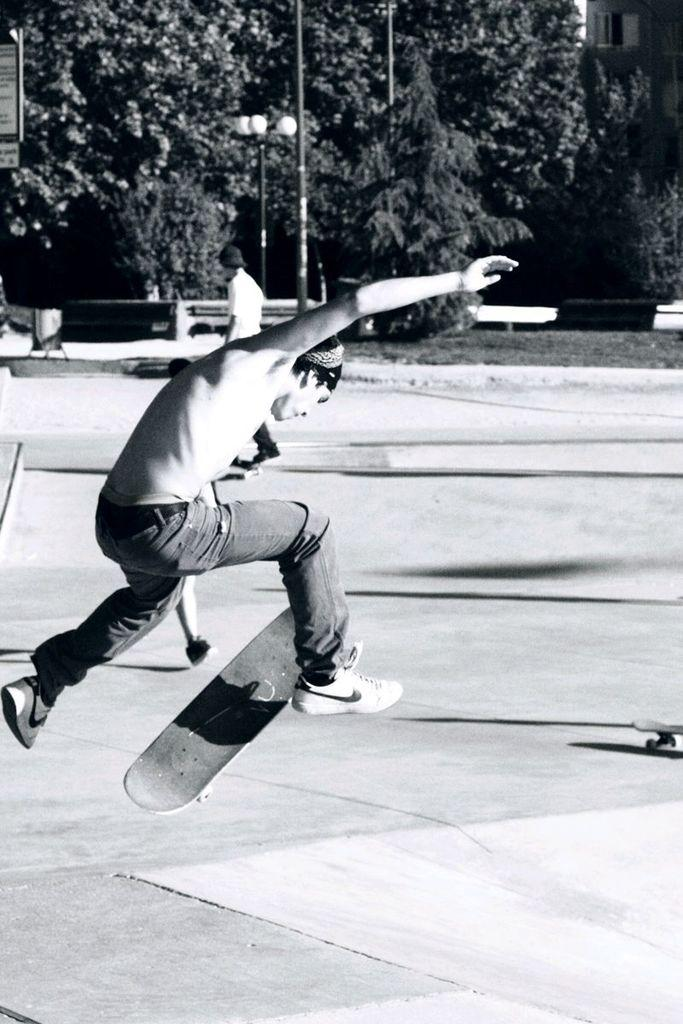Who is the main subject in the image? There is a boy in the image. What object is associated with the boy in the image? There is a skateboard in the image. What type of vegetation can be seen in the background of the image? There are green color trees in the background of the image. What type of lighting is present in the image? There are white color lights visible in the image. How many cats are visible in the image? There are no cats present in the image. What mark is the boy making on the skateboard in the image? The image does not show the boy making any mark on the skateboard. 